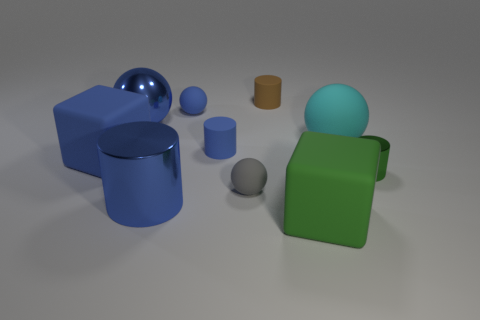Subtract all spheres. How many objects are left? 6 Add 5 small green spheres. How many small green spheres exist? 5 Subtract 0 brown spheres. How many objects are left? 10 Subtract all cyan things. Subtract all blue cylinders. How many objects are left? 7 Add 3 small metal things. How many small metal things are left? 4 